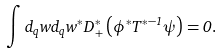Convert formula to latex. <formula><loc_0><loc_0><loc_500><loc_500>\int d _ { q } w d _ { q } w ^ { \ast } D _ { + } ^ { \ast } \left ( \phi ^ { \ast } T ^ { \ast - 1 } \psi \right ) = 0 .</formula> 